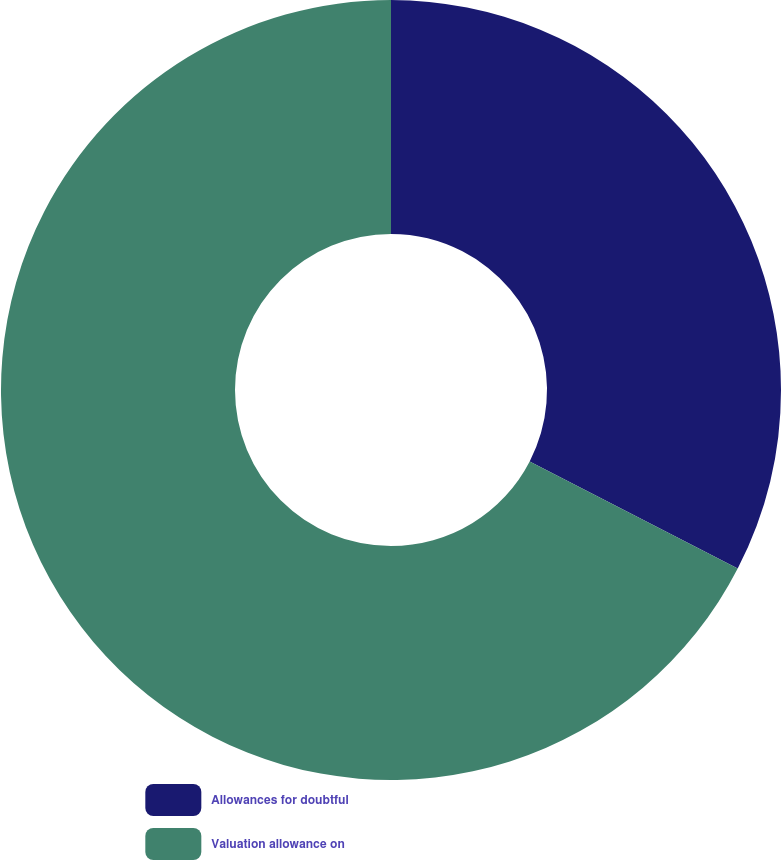<chart> <loc_0><loc_0><loc_500><loc_500><pie_chart><fcel>Allowances for doubtful<fcel>Valuation allowance on<nl><fcel>32.57%<fcel>67.43%<nl></chart> 